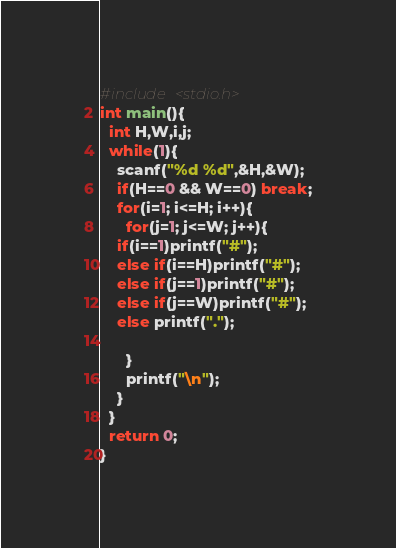Convert code to text. <code><loc_0><loc_0><loc_500><loc_500><_C_>#include <stdio.h>
int main(){
  int H,W,i,j;
  while(1){
    scanf("%d %d",&H,&W);
    if(H==0 && W==0) break;
    for(i=1; i<=H; i++){
      for(j=1; j<=W; j++){
	if(i==1)printf("#");
	else if(i==H)printf("#");
	else if(j==1)printf("#");
	else if(j==W)printf("#");
	else printf(".");
	
      }
      printf("\n");
    }
  }
  return 0;
}</code> 